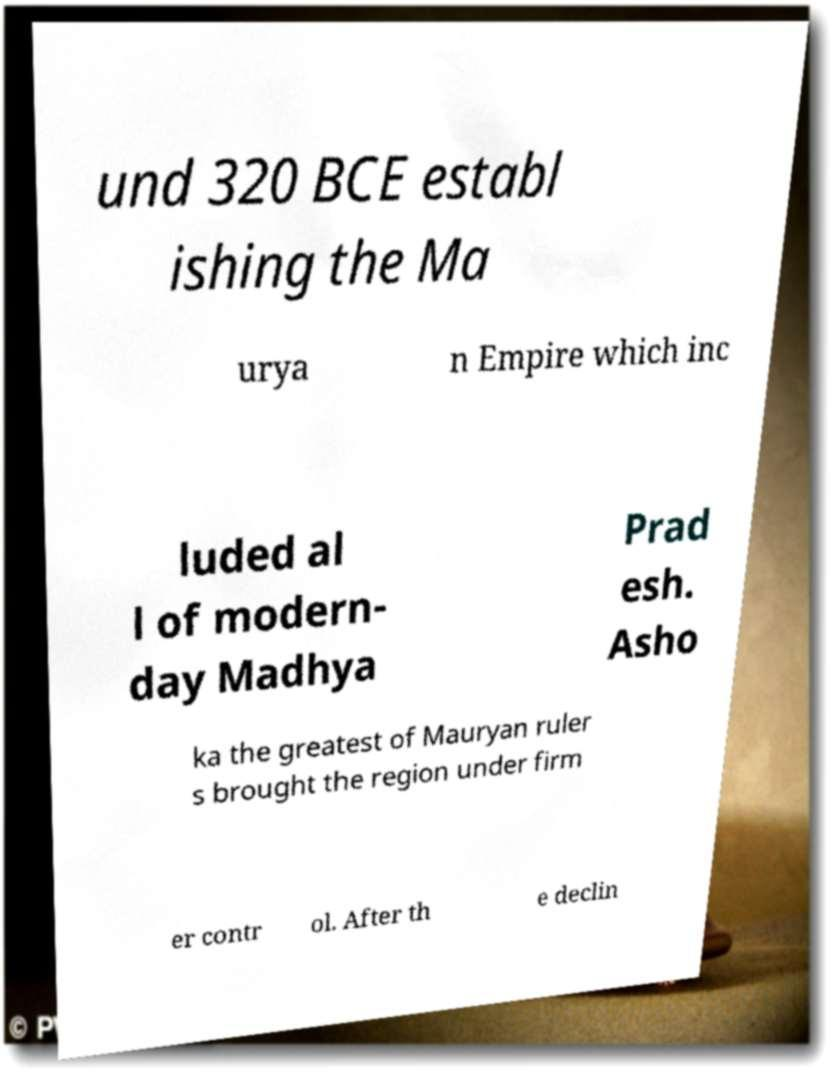Could you assist in decoding the text presented in this image and type it out clearly? und 320 BCE establ ishing the Ma urya n Empire which inc luded al l of modern- day Madhya Prad esh. Asho ka the greatest of Mauryan ruler s brought the region under firm er contr ol. After th e declin 